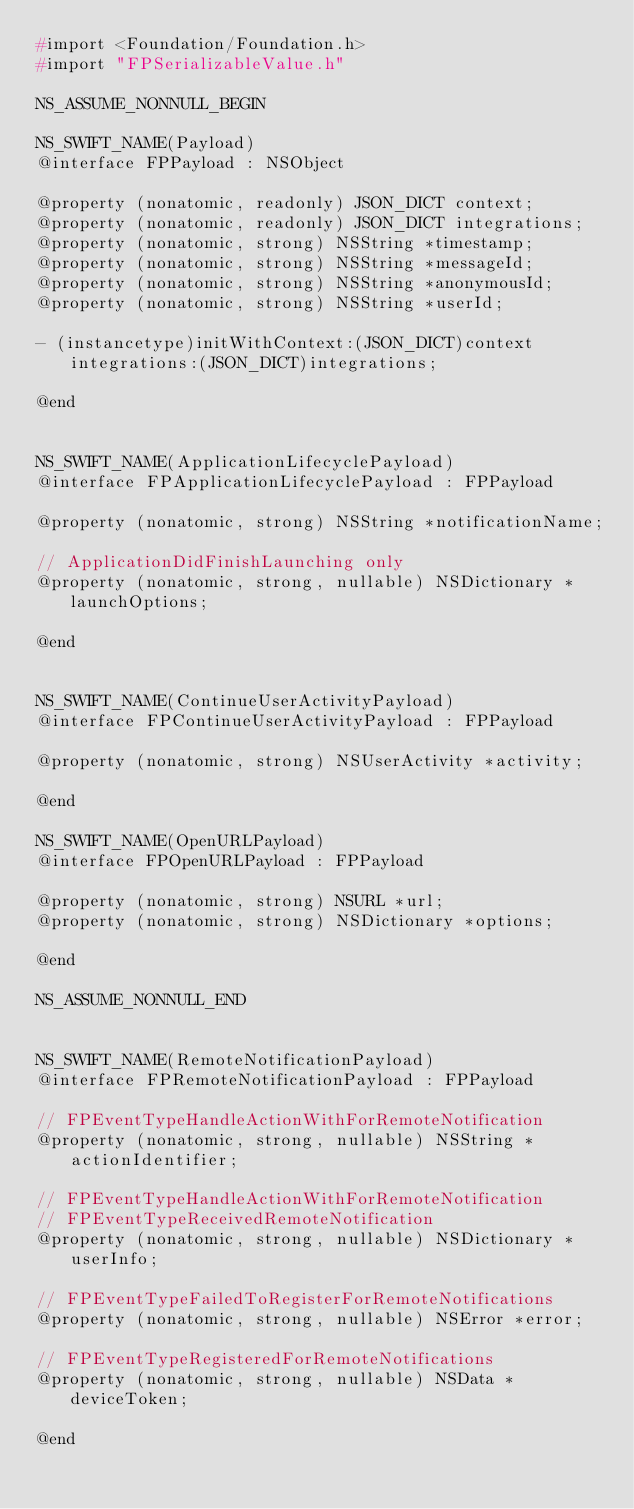Convert code to text. <code><loc_0><loc_0><loc_500><loc_500><_C_>#import <Foundation/Foundation.h>
#import "FPSerializableValue.h"

NS_ASSUME_NONNULL_BEGIN

NS_SWIFT_NAME(Payload)
@interface FPPayload : NSObject

@property (nonatomic, readonly) JSON_DICT context;
@property (nonatomic, readonly) JSON_DICT integrations;
@property (nonatomic, strong) NSString *timestamp;
@property (nonatomic, strong) NSString *messageId;
@property (nonatomic, strong) NSString *anonymousId;
@property (nonatomic, strong) NSString *userId;

- (instancetype)initWithContext:(JSON_DICT)context integrations:(JSON_DICT)integrations;

@end


NS_SWIFT_NAME(ApplicationLifecyclePayload)
@interface FPApplicationLifecyclePayload : FPPayload

@property (nonatomic, strong) NSString *notificationName;

// ApplicationDidFinishLaunching only
@property (nonatomic, strong, nullable) NSDictionary *launchOptions;

@end


NS_SWIFT_NAME(ContinueUserActivityPayload)
@interface FPContinueUserActivityPayload : FPPayload

@property (nonatomic, strong) NSUserActivity *activity;

@end

NS_SWIFT_NAME(OpenURLPayload)
@interface FPOpenURLPayload : FPPayload

@property (nonatomic, strong) NSURL *url;
@property (nonatomic, strong) NSDictionary *options;

@end

NS_ASSUME_NONNULL_END


NS_SWIFT_NAME(RemoteNotificationPayload)
@interface FPRemoteNotificationPayload : FPPayload

// FPEventTypeHandleActionWithForRemoteNotification
@property (nonatomic, strong, nullable) NSString *actionIdentifier;

// FPEventTypeHandleActionWithForRemoteNotification
// FPEventTypeReceivedRemoteNotification
@property (nonatomic, strong, nullable) NSDictionary *userInfo;

// FPEventTypeFailedToRegisterForRemoteNotifications
@property (nonatomic, strong, nullable) NSError *error;

// FPEventTypeRegisteredForRemoteNotifications
@property (nonatomic, strong, nullable) NSData *deviceToken;

@end
</code> 